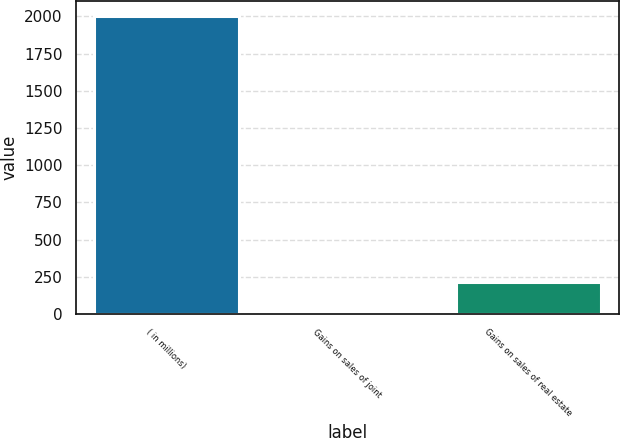Convert chart. <chart><loc_0><loc_0><loc_500><loc_500><bar_chart><fcel>( in millions)<fcel>Gains on sales of joint<fcel>Gains on sales of real estate<nl><fcel>2004<fcel>19<fcel>217.5<nl></chart> 